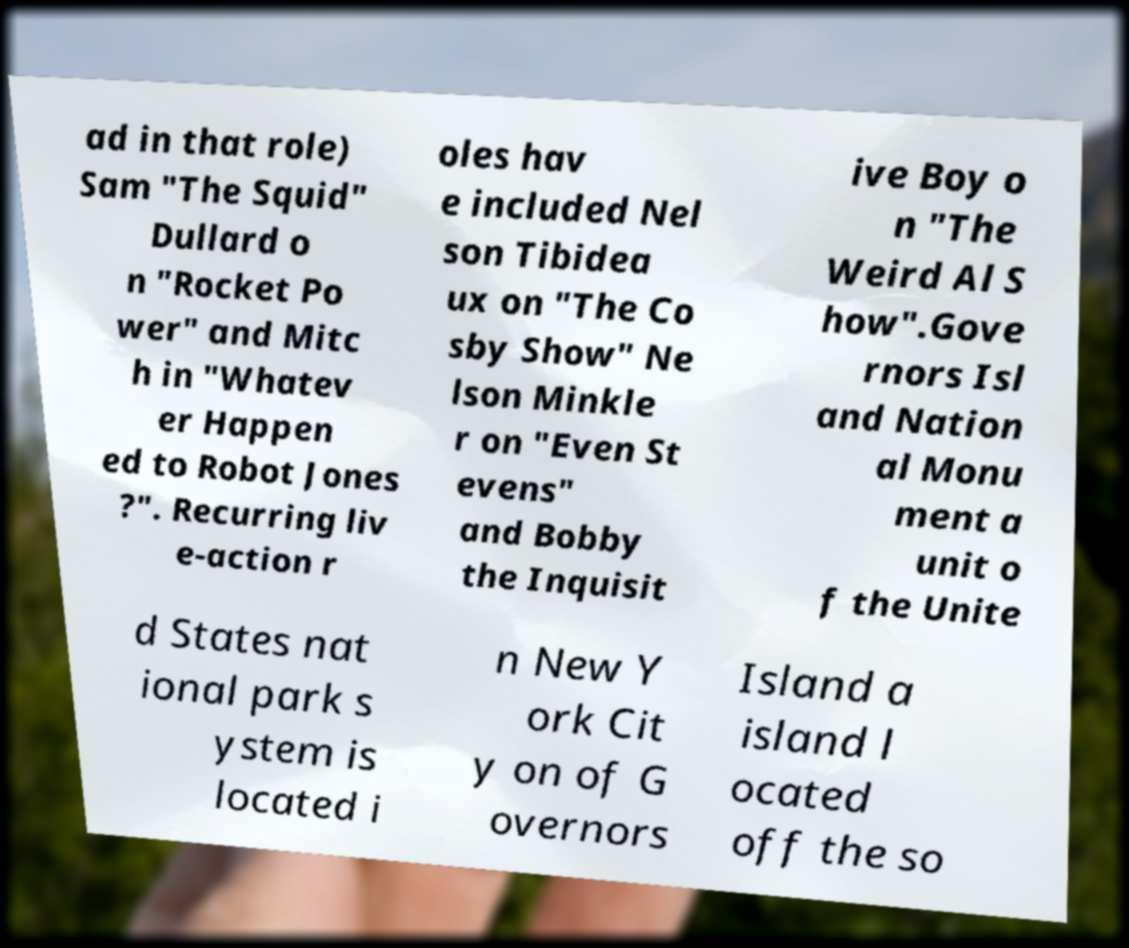Please read and relay the text visible in this image. What does it say? ad in that role) Sam "The Squid" Dullard o n "Rocket Po wer" and Mitc h in "Whatev er Happen ed to Robot Jones ?". Recurring liv e-action r oles hav e included Nel son Tibidea ux on "The Co sby Show" Ne lson Minkle r on "Even St evens" and Bobby the Inquisit ive Boy o n "The Weird Al S how".Gove rnors Isl and Nation al Monu ment a unit o f the Unite d States nat ional park s ystem is located i n New Y ork Cit y on of G overnors Island a island l ocated off the so 